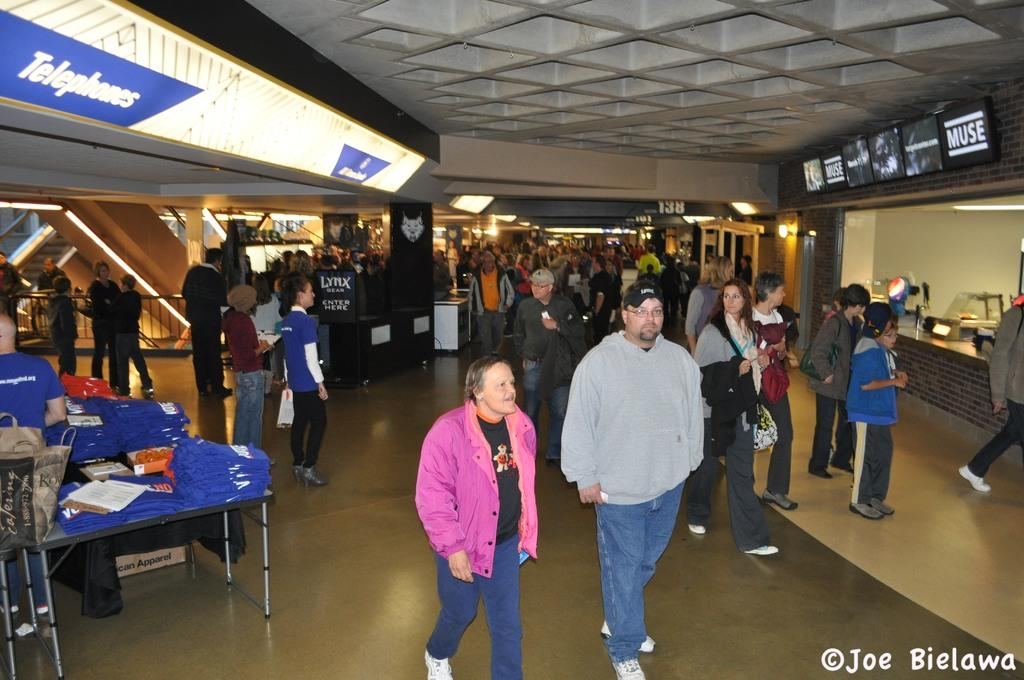How many people are in the image? There is a group of people in the image, but the exact number cannot be determined from the provided facts. What is the surface beneath the people in the image? There is a floor in the image. What type of furniture is present in the image? There are tables in the image. What items can be seen on the tables? Clothes, papers, and bags are on the table. What can be seen in the background of the image? There are lights, boards, and screens in the background of the image. What type of silk is draped over the spring in the image? There is no silk or spring present in the image. How far can the stretch of the screens be seen in the image? The screens in the background of the image do not have a visible stretch; they are stationary objects. 